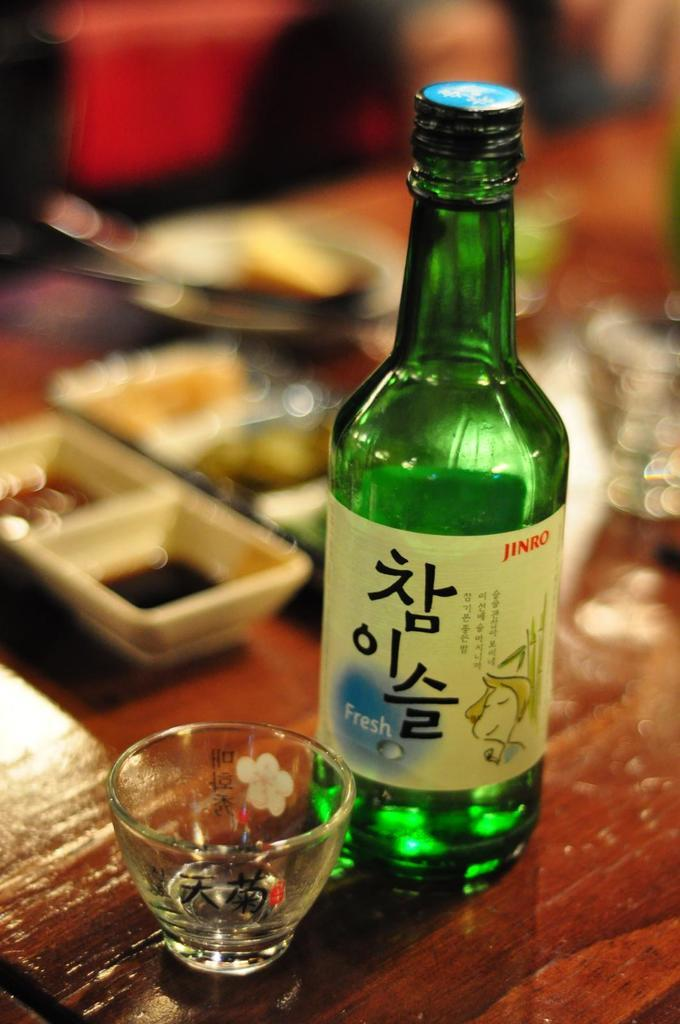<image>
Write a terse but informative summary of the picture. The green Jinro bottle to the right of the shot glass says Fresh. 